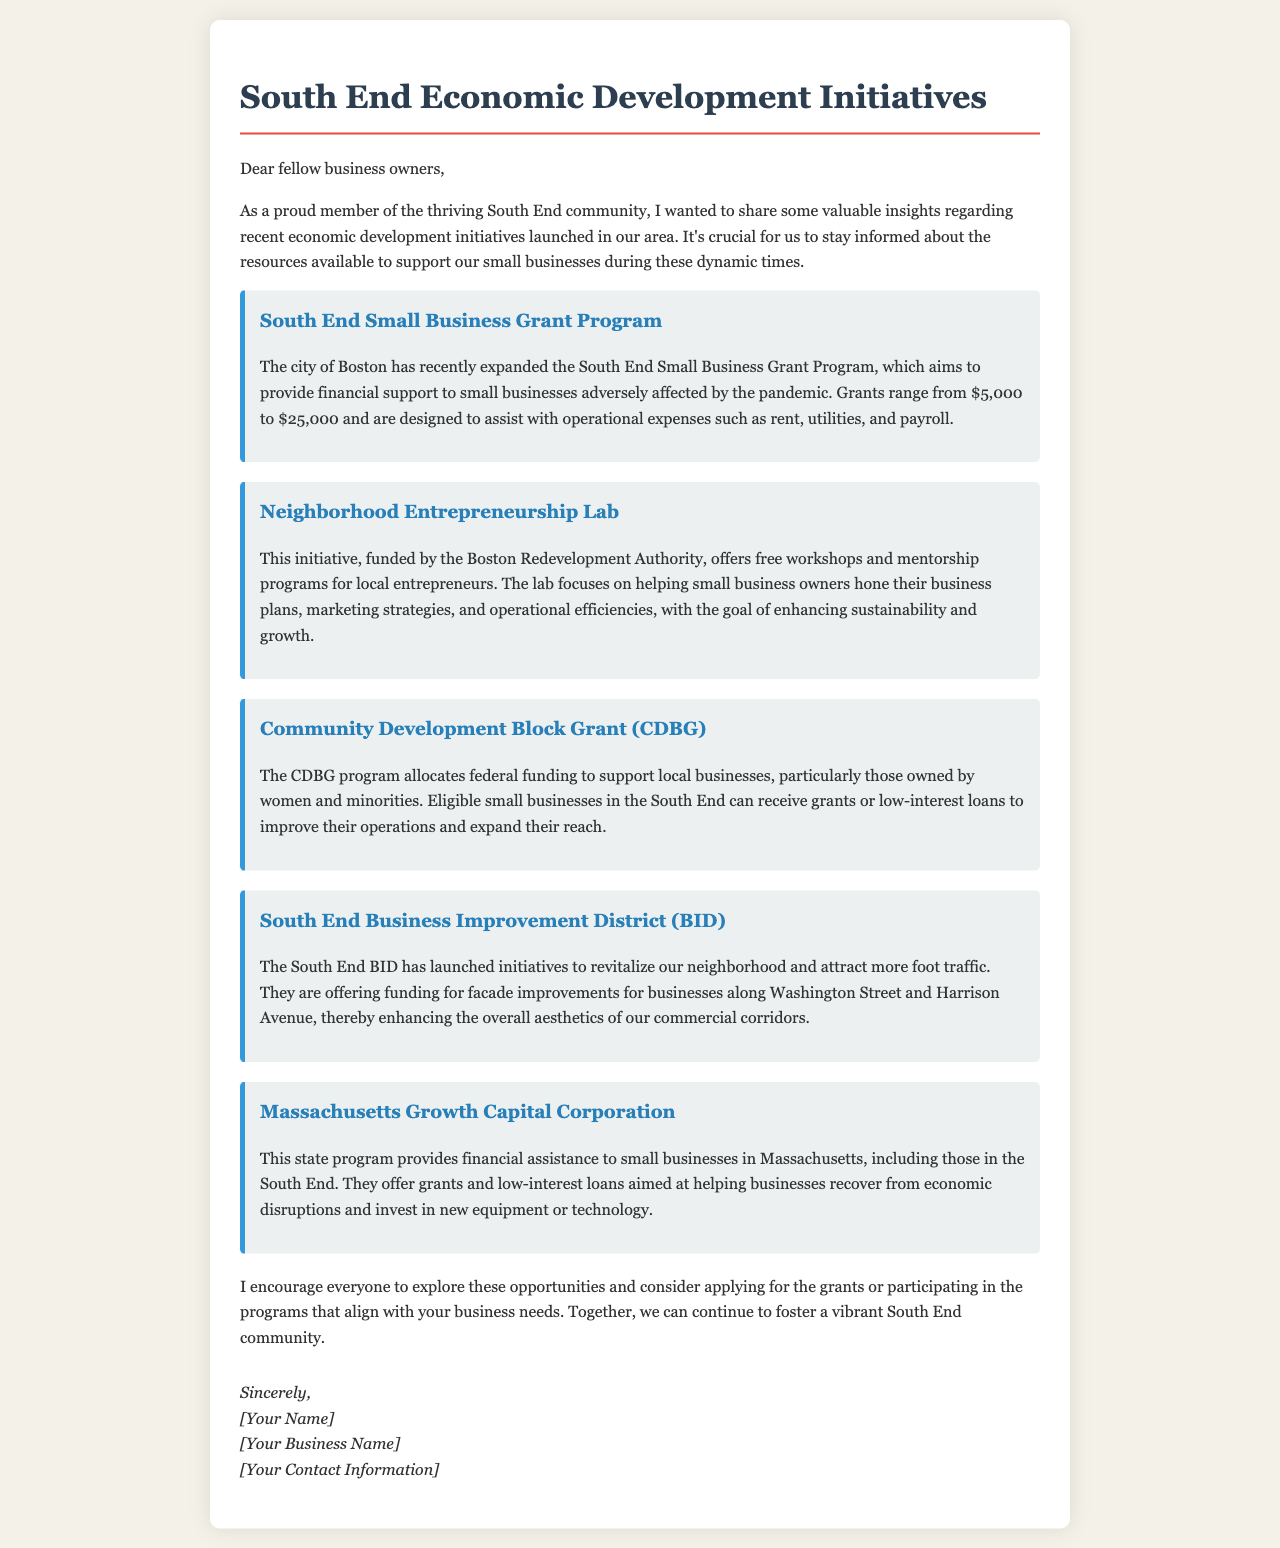what is the range of grants available in the South End Small Business Grant Program? The document states that grants range from $5,000 to $25,000.
Answer: $5,000 to $25,000 who funds the Neighborhood Entrepreneurship Lab? The Neighborhood Entrepreneurship Lab is funded by the Boston Redevelopment Authority.
Answer: Boston Redevelopment Authority what type of businesses does the CDBG program particularly support? The CDBG program particularly supports local businesses owned by women and minorities.
Answer: women and minorities what major initiative was launched to improve aesthetics along Washington Street and Harrison Avenue? The major initiative launched is funding for facade improvements for businesses along Washington Street and Harrison Avenue.
Answer: facade improvements what is the purpose of the Massachusetts Growth Capital Corporation program? The purpose is to provide financial assistance to small businesses to recover from economic disruptions and invest in new equipment or technology.
Answer: financial assistance what should business owners do to benefit from the initiatives mentioned in the document? Business owners should explore opportunities and consider applying for grants or participating in relevant programs.
Answer: explore opportunities and apply for grants how does the document conclude? The document concludes with a sincere closing from the author, providing their name, business name, and contact information.
Answer: a sincere closing what is the overall theme of the letter? The overall theme is to inform local business owners about recent economic development initiatives and available resources.
Answer: inform about economic development initiatives 